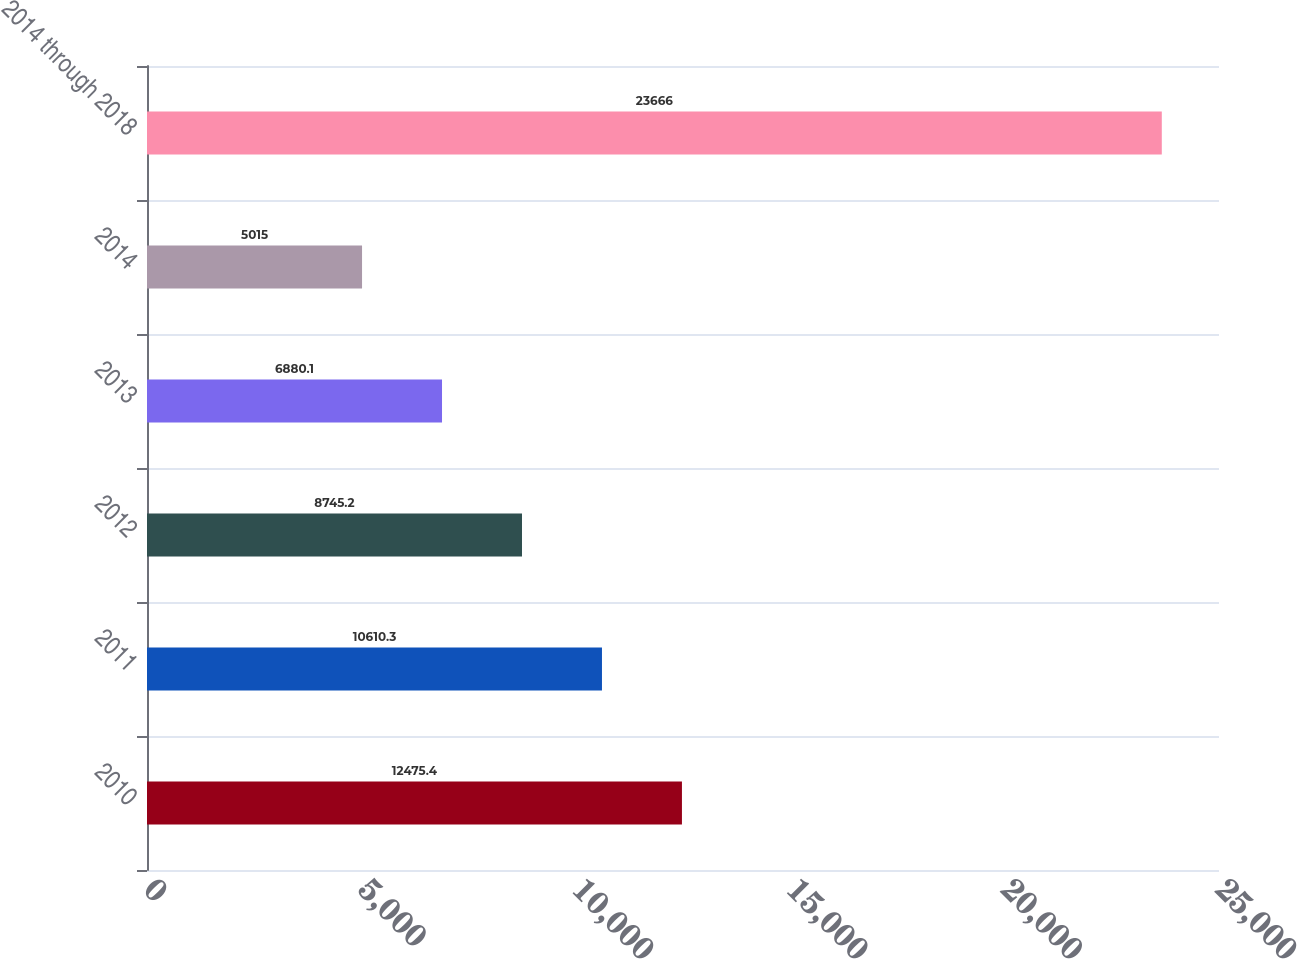Convert chart. <chart><loc_0><loc_0><loc_500><loc_500><bar_chart><fcel>2010<fcel>2011<fcel>2012<fcel>2013<fcel>2014<fcel>2014 through 2018<nl><fcel>12475.4<fcel>10610.3<fcel>8745.2<fcel>6880.1<fcel>5015<fcel>23666<nl></chart> 